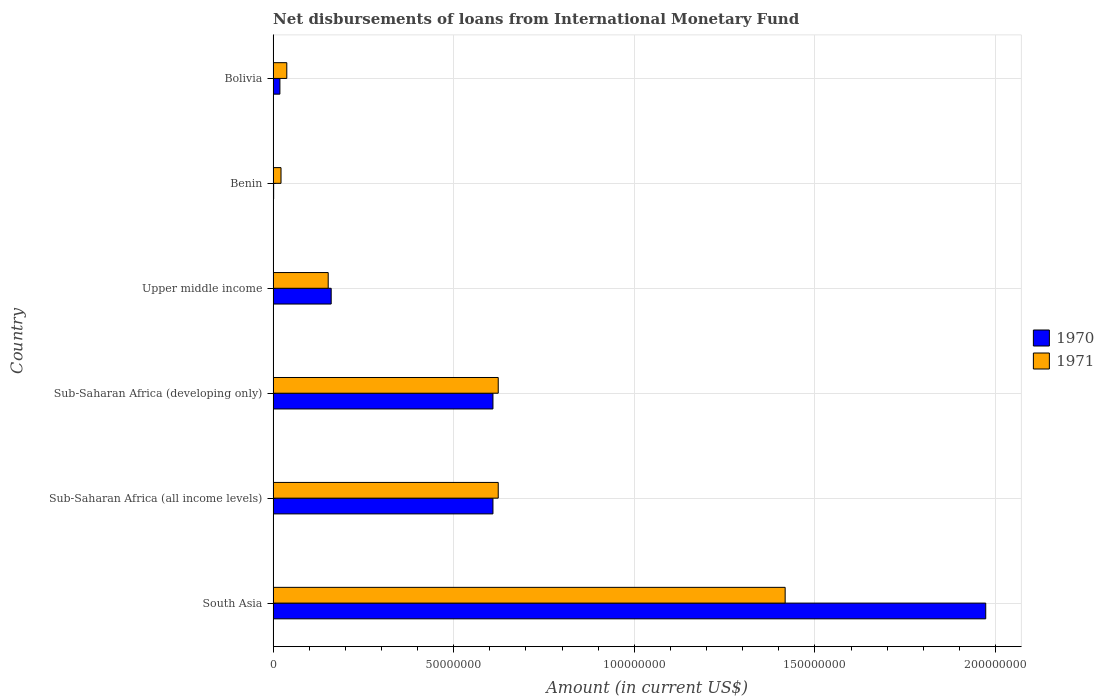What is the label of the 6th group of bars from the top?
Your answer should be very brief. South Asia. What is the amount of loans disbursed in 1971 in Bolivia?
Make the answer very short. 3.79e+06. Across all countries, what is the maximum amount of loans disbursed in 1971?
Keep it short and to the point. 1.42e+08. Across all countries, what is the minimum amount of loans disbursed in 1970?
Give a very brief answer. 1.45e+05. In which country was the amount of loans disbursed in 1971 maximum?
Keep it short and to the point. South Asia. In which country was the amount of loans disbursed in 1971 minimum?
Give a very brief answer. Benin. What is the total amount of loans disbursed in 1970 in the graph?
Keep it short and to the point. 3.37e+08. What is the difference between the amount of loans disbursed in 1970 in Benin and that in Sub-Saharan Africa (developing only)?
Make the answer very short. -6.07e+07. What is the difference between the amount of loans disbursed in 1970 in South Asia and the amount of loans disbursed in 1971 in Benin?
Keep it short and to the point. 1.95e+08. What is the average amount of loans disbursed in 1971 per country?
Provide a short and direct response. 4.79e+07. What is the difference between the amount of loans disbursed in 1971 and amount of loans disbursed in 1970 in Bolivia?
Provide a short and direct response. 1.91e+06. In how many countries, is the amount of loans disbursed in 1971 greater than 100000000 US$?
Give a very brief answer. 1. What is the ratio of the amount of loans disbursed in 1970 in Benin to that in Sub-Saharan Africa (developing only)?
Make the answer very short. 0. Is the amount of loans disbursed in 1971 in South Asia less than that in Sub-Saharan Africa (developing only)?
Keep it short and to the point. No. What is the difference between the highest and the second highest amount of loans disbursed in 1971?
Provide a short and direct response. 7.94e+07. What is the difference between the highest and the lowest amount of loans disbursed in 1971?
Offer a terse response. 1.40e+08. Is the sum of the amount of loans disbursed in 1970 in Bolivia and Sub-Saharan Africa (developing only) greater than the maximum amount of loans disbursed in 1971 across all countries?
Your response must be concise. No. What does the 2nd bar from the top in Sub-Saharan Africa (all income levels) represents?
Your answer should be compact. 1970. What does the 1st bar from the bottom in Upper middle income represents?
Offer a very short reply. 1970. How are the legend labels stacked?
Offer a very short reply. Vertical. What is the title of the graph?
Offer a very short reply. Net disbursements of loans from International Monetary Fund. Does "2004" appear as one of the legend labels in the graph?
Your answer should be very brief. No. What is the Amount (in current US$) of 1970 in South Asia?
Ensure brevity in your answer.  1.97e+08. What is the Amount (in current US$) of 1971 in South Asia?
Give a very brief answer. 1.42e+08. What is the Amount (in current US$) in 1970 in Sub-Saharan Africa (all income levels)?
Give a very brief answer. 6.09e+07. What is the Amount (in current US$) in 1971 in Sub-Saharan Africa (all income levels)?
Offer a terse response. 6.23e+07. What is the Amount (in current US$) of 1970 in Sub-Saharan Africa (developing only)?
Your answer should be very brief. 6.09e+07. What is the Amount (in current US$) of 1971 in Sub-Saharan Africa (developing only)?
Your answer should be compact. 6.23e+07. What is the Amount (in current US$) in 1970 in Upper middle income?
Give a very brief answer. 1.61e+07. What is the Amount (in current US$) of 1971 in Upper middle income?
Provide a short and direct response. 1.52e+07. What is the Amount (in current US$) of 1970 in Benin?
Make the answer very short. 1.45e+05. What is the Amount (in current US$) in 1971 in Benin?
Ensure brevity in your answer.  2.19e+06. What is the Amount (in current US$) of 1970 in Bolivia?
Your answer should be very brief. 1.88e+06. What is the Amount (in current US$) in 1971 in Bolivia?
Keep it short and to the point. 3.79e+06. Across all countries, what is the maximum Amount (in current US$) in 1970?
Offer a terse response. 1.97e+08. Across all countries, what is the maximum Amount (in current US$) of 1971?
Offer a terse response. 1.42e+08. Across all countries, what is the minimum Amount (in current US$) of 1970?
Provide a short and direct response. 1.45e+05. Across all countries, what is the minimum Amount (in current US$) of 1971?
Keep it short and to the point. 2.19e+06. What is the total Amount (in current US$) in 1970 in the graph?
Your response must be concise. 3.37e+08. What is the total Amount (in current US$) in 1971 in the graph?
Keep it short and to the point. 2.88e+08. What is the difference between the Amount (in current US$) in 1970 in South Asia and that in Sub-Saharan Africa (all income levels)?
Your answer should be compact. 1.36e+08. What is the difference between the Amount (in current US$) of 1971 in South Asia and that in Sub-Saharan Africa (all income levels)?
Provide a short and direct response. 7.94e+07. What is the difference between the Amount (in current US$) in 1970 in South Asia and that in Sub-Saharan Africa (developing only)?
Offer a very short reply. 1.36e+08. What is the difference between the Amount (in current US$) in 1971 in South Asia and that in Sub-Saharan Africa (developing only)?
Offer a terse response. 7.94e+07. What is the difference between the Amount (in current US$) of 1970 in South Asia and that in Upper middle income?
Make the answer very short. 1.81e+08. What is the difference between the Amount (in current US$) in 1971 in South Asia and that in Upper middle income?
Make the answer very short. 1.26e+08. What is the difference between the Amount (in current US$) in 1970 in South Asia and that in Benin?
Offer a very short reply. 1.97e+08. What is the difference between the Amount (in current US$) in 1971 in South Asia and that in Benin?
Provide a short and direct response. 1.40e+08. What is the difference between the Amount (in current US$) in 1970 in South Asia and that in Bolivia?
Offer a very short reply. 1.95e+08. What is the difference between the Amount (in current US$) in 1971 in South Asia and that in Bolivia?
Keep it short and to the point. 1.38e+08. What is the difference between the Amount (in current US$) of 1970 in Sub-Saharan Africa (all income levels) and that in Sub-Saharan Africa (developing only)?
Provide a short and direct response. 0. What is the difference between the Amount (in current US$) in 1970 in Sub-Saharan Africa (all income levels) and that in Upper middle income?
Offer a very short reply. 4.48e+07. What is the difference between the Amount (in current US$) of 1971 in Sub-Saharan Africa (all income levels) and that in Upper middle income?
Offer a very short reply. 4.71e+07. What is the difference between the Amount (in current US$) in 1970 in Sub-Saharan Africa (all income levels) and that in Benin?
Provide a short and direct response. 6.07e+07. What is the difference between the Amount (in current US$) in 1971 in Sub-Saharan Africa (all income levels) and that in Benin?
Your response must be concise. 6.01e+07. What is the difference between the Amount (in current US$) in 1970 in Sub-Saharan Africa (all income levels) and that in Bolivia?
Offer a terse response. 5.90e+07. What is the difference between the Amount (in current US$) in 1971 in Sub-Saharan Africa (all income levels) and that in Bolivia?
Your response must be concise. 5.85e+07. What is the difference between the Amount (in current US$) of 1970 in Sub-Saharan Africa (developing only) and that in Upper middle income?
Make the answer very short. 4.48e+07. What is the difference between the Amount (in current US$) in 1971 in Sub-Saharan Africa (developing only) and that in Upper middle income?
Ensure brevity in your answer.  4.71e+07. What is the difference between the Amount (in current US$) of 1970 in Sub-Saharan Africa (developing only) and that in Benin?
Keep it short and to the point. 6.07e+07. What is the difference between the Amount (in current US$) in 1971 in Sub-Saharan Africa (developing only) and that in Benin?
Give a very brief answer. 6.01e+07. What is the difference between the Amount (in current US$) of 1970 in Sub-Saharan Africa (developing only) and that in Bolivia?
Provide a succinct answer. 5.90e+07. What is the difference between the Amount (in current US$) of 1971 in Sub-Saharan Africa (developing only) and that in Bolivia?
Keep it short and to the point. 5.85e+07. What is the difference between the Amount (in current US$) of 1970 in Upper middle income and that in Benin?
Offer a very short reply. 1.59e+07. What is the difference between the Amount (in current US$) of 1971 in Upper middle income and that in Benin?
Offer a terse response. 1.31e+07. What is the difference between the Amount (in current US$) in 1970 in Upper middle income and that in Bolivia?
Make the answer very short. 1.42e+07. What is the difference between the Amount (in current US$) in 1971 in Upper middle income and that in Bolivia?
Make the answer very short. 1.15e+07. What is the difference between the Amount (in current US$) in 1970 in Benin and that in Bolivia?
Ensure brevity in your answer.  -1.73e+06. What is the difference between the Amount (in current US$) of 1971 in Benin and that in Bolivia?
Keep it short and to the point. -1.60e+06. What is the difference between the Amount (in current US$) of 1970 in South Asia and the Amount (in current US$) of 1971 in Sub-Saharan Africa (all income levels)?
Your answer should be very brief. 1.35e+08. What is the difference between the Amount (in current US$) in 1970 in South Asia and the Amount (in current US$) in 1971 in Sub-Saharan Africa (developing only)?
Give a very brief answer. 1.35e+08. What is the difference between the Amount (in current US$) in 1970 in South Asia and the Amount (in current US$) in 1971 in Upper middle income?
Give a very brief answer. 1.82e+08. What is the difference between the Amount (in current US$) of 1970 in South Asia and the Amount (in current US$) of 1971 in Benin?
Offer a very short reply. 1.95e+08. What is the difference between the Amount (in current US$) of 1970 in South Asia and the Amount (in current US$) of 1971 in Bolivia?
Offer a terse response. 1.93e+08. What is the difference between the Amount (in current US$) in 1970 in Sub-Saharan Africa (all income levels) and the Amount (in current US$) in 1971 in Sub-Saharan Africa (developing only)?
Ensure brevity in your answer.  -1.46e+06. What is the difference between the Amount (in current US$) in 1970 in Sub-Saharan Africa (all income levels) and the Amount (in current US$) in 1971 in Upper middle income?
Offer a terse response. 4.56e+07. What is the difference between the Amount (in current US$) in 1970 in Sub-Saharan Africa (all income levels) and the Amount (in current US$) in 1971 in Benin?
Keep it short and to the point. 5.87e+07. What is the difference between the Amount (in current US$) of 1970 in Sub-Saharan Africa (all income levels) and the Amount (in current US$) of 1971 in Bolivia?
Provide a short and direct response. 5.71e+07. What is the difference between the Amount (in current US$) of 1970 in Sub-Saharan Africa (developing only) and the Amount (in current US$) of 1971 in Upper middle income?
Offer a terse response. 4.56e+07. What is the difference between the Amount (in current US$) in 1970 in Sub-Saharan Africa (developing only) and the Amount (in current US$) in 1971 in Benin?
Provide a short and direct response. 5.87e+07. What is the difference between the Amount (in current US$) in 1970 in Sub-Saharan Africa (developing only) and the Amount (in current US$) in 1971 in Bolivia?
Ensure brevity in your answer.  5.71e+07. What is the difference between the Amount (in current US$) in 1970 in Upper middle income and the Amount (in current US$) in 1971 in Benin?
Keep it short and to the point. 1.39e+07. What is the difference between the Amount (in current US$) of 1970 in Upper middle income and the Amount (in current US$) of 1971 in Bolivia?
Give a very brief answer. 1.23e+07. What is the difference between the Amount (in current US$) in 1970 in Benin and the Amount (in current US$) in 1971 in Bolivia?
Provide a short and direct response. -3.64e+06. What is the average Amount (in current US$) in 1970 per country?
Offer a terse response. 5.62e+07. What is the average Amount (in current US$) of 1971 per country?
Offer a very short reply. 4.79e+07. What is the difference between the Amount (in current US$) of 1970 and Amount (in current US$) of 1971 in South Asia?
Ensure brevity in your answer.  5.55e+07. What is the difference between the Amount (in current US$) in 1970 and Amount (in current US$) in 1971 in Sub-Saharan Africa (all income levels)?
Give a very brief answer. -1.46e+06. What is the difference between the Amount (in current US$) in 1970 and Amount (in current US$) in 1971 in Sub-Saharan Africa (developing only)?
Give a very brief answer. -1.46e+06. What is the difference between the Amount (in current US$) in 1970 and Amount (in current US$) in 1971 in Upper middle income?
Your answer should be very brief. 8.24e+05. What is the difference between the Amount (in current US$) of 1970 and Amount (in current US$) of 1971 in Benin?
Offer a very short reply. -2.04e+06. What is the difference between the Amount (in current US$) of 1970 and Amount (in current US$) of 1971 in Bolivia?
Offer a very short reply. -1.91e+06. What is the ratio of the Amount (in current US$) of 1970 in South Asia to that in Sub-Saharan Africa (all income levels)?
Provide a succinct answer. 3.24. What is the ratio of the Amount (in current US$) of 1971 in South Asia to that in Sub-Saharan Africa (all income levels)?
Provide a succinct answer. 2.27. What is the ratio of the Amount (in current US$) in 1970 in South Asia to that in Sub-Saharan Africa (developing only)?
Offer a terse response. 3.24. What is the ratio of the Amount (in current US$) in 1971 in South Asia to that in Sub-Saharan Africa (developing only)?
Give a very brief answer. 2.27. What is the ratio of the Amount (in current US$) of 1970 in South Asia to that in Upper middle income?
Offer a very short reply. 12.27. What is the ratio of the Amount (in current US$) of 1971 in South Asia to that in Upper middle income?
Your answer should be compact. 9.29. What is the ratio of the Amount (in current US$) of 1970 in South Asia to that in Benin?
Ensure brevity in your answer.  1360.52. What is the ratio of the Amount (in current US$) of 1971 in South Asia to that in Benin?
Your response must be concise. 64.84. What is the ratio of the Amount (in current US$) in 1970 in South Asia to that in Bolivia?
Your response must be concise. 104.99. What is the ratio of the Amount (in current US$) of 1971 in South Asia to that in Bolivia?
Offer a very short reply. 37.43. What is the ratio of the Amount (in current US$) of 1970 in Sub-Saharan Africa (all income levels) to that in Upper middle income?
Offer a terse response. 3.79. What is the ratio of the Amount (in current US$) of 1971 in Sub-Saharan Africa (all income levels) to that in Upper middle income?
Give a very brief answer. 4.09. What is the ratio of the Amount (in current US$) of 1970 in Sub-Saharan Africa (all income levels) to that in Benin?
Your answer should be compact. 419.7. What is the ratio of the Amount (in current US$) of 1971 in Sub-Saharan Africa (all income levels) to that in Benin?
Give a very brief answer. 28.51. What is the ratio of the Amount (in current US$) in 1970 in Sub-Saharan Africa (all income levels) to that in Bolivia?
Give a very brief answer. 32.39. What is the ratio of the Amount (in current US$) in 1971 in Sub-Saharan Africa (all income levels) to that in Bolivia?
Provide a short and direct response. 16.46. What is the ratio of the Amount (in current US$) in 1970 in Sub-Saharan Africa (developing only) to that in Upper middle income?
Your response must be concise. 3.79. What is the ratio of the Amount (in current US$) in 1971 in Sub-Saharan Africa (developing only) to that in Upper middle income?
Your response must be concise. 4.09. What is the ratio of the Amount (in current US$) in 1970 in Sub-Saharan Africa (developing only) to that in Benin?
Offer a very short reply. 419.7. What is the ratio of the Amount (in current US$) in 1971 in Sub-Saharan Africa (developing only) to that in Benin?
Ensure brevity in your answer.  28.51. What is the ratio of the Amount (in current US$) of 1970 in Sub-Saharan Africa (developing only) to that in Bolivia?
Offer a terse response. 32.39. What is the ratio of the Amount (in current US$) in 1971 in Sub-Saharan Africa (developing only) to that in Bolivia?
Offer a terse response. 16.46. What is the ratio of the Amount (in current US$) in 1970 in Upper middle income to that in Benin?
Give a very brief answer. 110.86. What is the ratio of the Amount (in current US$) in 1971 in Upper middle income to that in Benin?
Provide a succinct answer. 6.98. What is the ratio of the Amount (in current US$) of 1970 in Upper middle income to that in Bolivia?
Give a very brief answer. 8.55. What is the ratio of the Amount (in current US$) in 1971 in Upper middle income to that in Bolivia?
Provide a short and direct response. 4.03. What is the ratio of the Amount (in current US$) of 1970 in Benin to that in Bolivia?
Offer a very short reply. 0.08. What is the ratio of the Amount (in current US$) of 1971 in Benin to that in Bolivia?
Your answer should be very brief. 0.58. What is the difference between the highest and the second highest Amount (in current US$) of 1970?
Offer a very short reply. 1.36e+08. What is the difference between the highest and the second highest Amount (in current US$) of 1971?
Keep it short and to the point. 7.94e+07. What is the difference between the highest and the lowest Amount (in current US$) of 1970?
Keep it short and to the point. 1.97e+08. What is the difference between the highest and the lowest Amount (in current US$) in 1971?
Your answer should be very brief. 1.40e+08. 